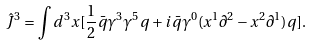Convert formula to latex. <formula><loc_0><loc_0><loc_500><loc_500>\hat { J } ^ { 3 } = \int d ^ { 3 } x [ \frac { 1 } { 2 } \bar { q } \gamma ^ { 3 } \gamma ^ { 5 } q + i \bar { q } \gamma ^ { 0 } ( x ^ { 1 } \partial ^ { 2 } - x ^ { 2 } \partial ^ { 1 } ) q ] .</formula> 